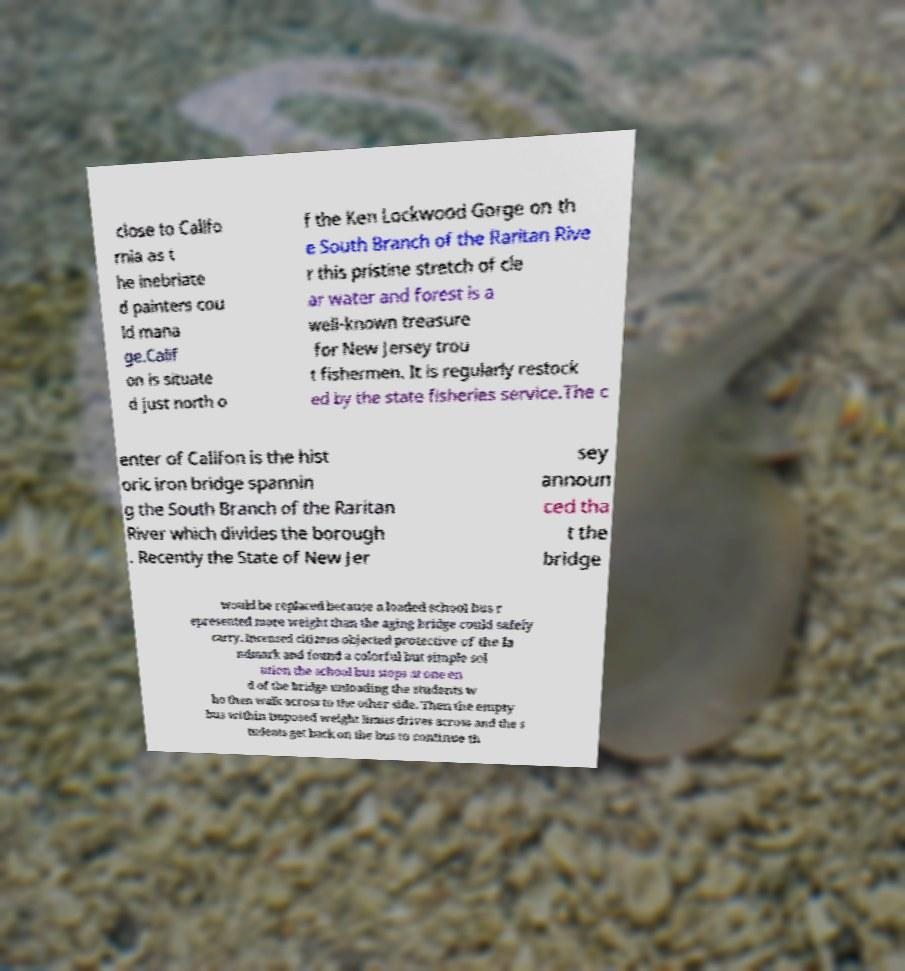Could you extract and type out the text from this image? close to Califo rnia as t he inebriate d painters cou ld mana ge.Calif on is situate d just north o f the Ken Lockwood Gorge on th e South Branch of the Raritan Rive r this pristine stretch of cle ar water and forest is a well-known treasure for New Jersey trou t fishermen. It is regularly restock ed by the state fisheries service.The c enter of Califon is the hist oric iron bridge spannin g the South Branch of the Raritan River which divides the borough . Recently the State of New Jer sey announ ced tha t the bridge would be replaced because a loaded school bus r epresented more weight than the aging bridge could safely carry. Incensed citizens objected protective of the la ndmark and found a colorful but simple sol ution the school bus stops at one en d of the bridge unloading the students w ho then walk across to the other side. Then the empty bus within imposed weight limits drives across and the s tudents get back on the bus to continue th 